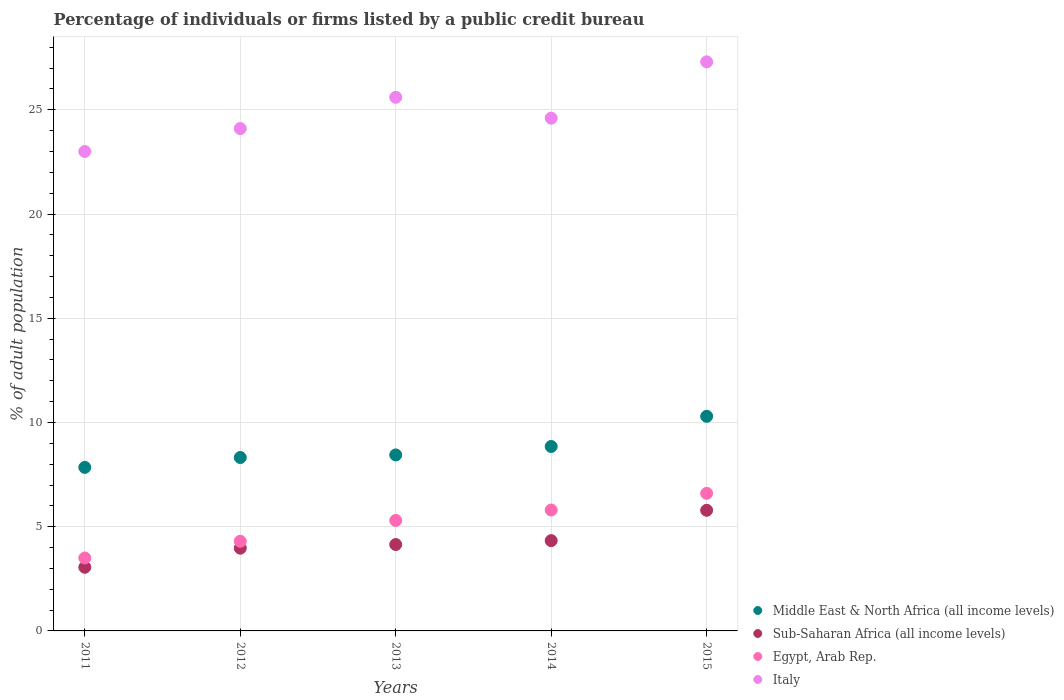What is the percentage of population listed by a public credit bureau in Middle East & North Africa (all income levels) in 2012?
Give a very brief answer. 8.32. Across all years, what is the maximum percentage of population listed by a public credit bureau in Middle East & North Africa (all income levels)?
Provide a short and direct response. 10.3. Across all years, what is the minimum percentage of population listed by a public credit bureau in Middle East & North Africa (all income levels)?
Provide a short and direct response. 7.84. In which year was the percentage of population listed by a public credit bureau in Egypt, Arab Rep. maximum?
Make the answer very short. 2015. What is the total percentage of population listed by a public credit bureau in Middle East & North Africa (all income levels) in the graph?
Provide a succinct answer. 43.75. What is the difference between the percentage of population listed by a public credit bureau in Egypt, Arab Rep. in 2014 and that in 2015?
Give a very brief answer. -0.8. What is the difference between the percentage of population listed by a public credit bureau in Italy in 2011 and the percentage of population listed by a public credit bureau in Sub-Saharan Africa (all income levels) in 2013?
Ensure brevity in your answer.  18.86. What is the average percentage of population listed by a public credit bureau in Middle East & North Africa (all income levels) per year?
Ensure brevity in your answer.  8.75. In the year 2012, what is the difference between the percentage of population listed by a public credit bureau in Sub-Saharan Africa (all income levels) and percentage of population listed by a public credit bureau in Italy?
Keep it short and to the point. -20.13. In how many years, is the percentage of population listed by a public credit bureau in Sub-Saharan Africa (all income levels) greater than 1 %?
Your answer should be compact. 5. What is the ratio of the percentage of population listed by a public credit bureau in Italy in 2013 to that in 2015?
Your response must be concise. 0.94. Is the difference between the percentage of population listed by a public credit bureau in Sub-Saharan Africa (all income levels) in 2012 and 2014 greater than the difference between the percentage of population listed by a public credit bureau in Italy in 2012 and 2014?
Your answer should be very brief. Yes. What is the difference between the highest and the second highest percentage of population listed by a public credit bureau in Italy?
Your answer should be very brief. 1.7. What is the difference between the highest and the lowest percentage of population listed by a public credit bureau in Egypt, Arab Rep.?
Offer a terse response. 3.1. In how many years, is the percentage of population listed by a public credit bureau in Italy greater than the average percentage of population listed by a public credit bureau in Italy taken over all years?
Ensure brevity in your answer.  2. Is it the case that in every year, the sum of the percentage of population listed by a public credit bureau in Sub-Saharan Africa (all income levels) and percentage of population listed by a public credit bureau in Egypt, Arab Rep.  is greater than the sum of percentage of population listed by a public credit bureau in Italy and percentage of population listed by a public credit bureau in Middle East & North Africa (all income levels)?
Make the answer very short. No. Is the percentage of population listed by a public credit bureau in Sub-Saharan Africa (all income levels) strictly greater than the percentage of population listed by a public credit bureau in Egypt, Arab Rep. over the years?
Ensure brevity in your answer.  No. Is the percentage of population listed by a public credit bureau in Sub-Saharan Africa (all income levels) strictly less than the percentage of population listed by a public credit bureau in Middle East & North Africa (all income levels) over the years?
Give a very brief answer. Yes. Are the values on the major ticks of Y-axis written in scientific E-notation?
Give a very brief answer. No. How many legend labels are there?
Your response must be concise. 4. What is the title of the graph?
Make the answer very short. Percentage of individuals or firms listed by a public credit bureau. Does "San Marino" appear as one of the legend labels in the graph?
Provide a short and direct response. No. What is the label or title of the Y-axis?
Provide a succinct answer. % of adult population. What is the % of adult population in Middle East & North Africa (all income levels) in 2011?
Ensure brevity in your answer.  7.84. What is the % of adult population in Sub-Saharan Africa (all income levels) in 2011?
Your answer should be very brief. 3.05. What is the % of adult population in Middle East & North Africa (all income levels) in 2012?
Make the answer very short. 8.32. What is the % of adult population of Sub-Saharan Africa (all income levels) in 2012?
Keep it short and to the point. 3.97. What is the % of adult population in Egypt, Arab Rep. in 2012?
Your answer should be very brief. 4.3. What is the % of adult population in Italy in 2012?
Ensure brevity in your answer.  24.1. What is the % of adult population in Middle East & North Africa (all income levels) in 2013?
Offer a very short reply. 8.44. What is the % of adult population of Sub-Saharan Africa (all income levels) in 2013?
Ensure brevity in your answer.  4.14. What is the % of adult population of Egypt, Arab Rep. in 2013?
Ensure brevity in your answer.  5.3. What is the % of adult population in Italy in 2013?
Make the answer very short. 25.6. What is the % of adult population in Middle East & North Africa (all income levels) in 2014?
Make the answer very short. 8.85. What is the % of adult population in Sub-Saharan Africa (all income levels) in 2014?
Your answer should be very brief. 4.33. What is the % of adult population in Italy in 2014?
Provide a succinct answer. 24.6. What is the % of adult population of Middle East & North Africa (all income levels) in 2015?
Your answer should be very brief. 10.3. What is the % of adult population of Sub-Saharan Africa (all income levels) in 2015?
Make the answer very short. 5.79. What is the % of adult population of Italy in 2015?
Your response must be concise. 27.3. Across all years, what is the maximum % of adult population of Middle East & North Africa (all income levels)?
Make the answer very short. 10.3. Across all years, what is the maximum % of adult population in Sub-Saharan Africa (all income levels)?
Make the answer very short. 5.79. Across all years, what is the maximum % of adult population of Egypt, Arab Rep.?
Your response must be concise. 6.6. Across all years, what is the maximum % of adult population in Italy?
Your answer should be compact. 27.3. Across all years, what is the minimum % of adult population in Middle East & North Africa (all income levels)?
Provide a short and direct response. 7.84. Across all years, what is the minimum % of adult population of Sub-Saharan Africa (all income levels)?
Keep it short and to the point. 3.05. Across all years, what is the minimum % of adult population of Egypt, Arab Rep.?
Offer a very short reply. 3.5. What is the total % of adult population of Middle East & North Africa (all income levels) in the graph?
Offer a terse response. 43.75. What is the total % of adult population of Sub-Saharan Africa (all income levels) in the graph?
Give a very brief answer. 21.29. What is the total % of adult population of Egypt, Arab Rep. in the graph?
Make the answer very short. 25.5. What is the total % of adult population of Italy in the graph?
Give a very brief answer. 124.6. What is the difference between the % of adult population of Middle East & North Africa (all income levels) in 2011 and that in 2012?
Provide a succinct answer. -0.47. What is the difference between the % of adult population of Sub-Saharan Africa (all income levels) in 2011 and that in 2012?
Provide a succinct answer. -0.92. What is the difference between the % of adult population of Italy in 2011 and that in 2012?
Provide a short and direct response. -1.1. What is the difference between the % of adult population of Middle East & North Africa (all income levels) in 2011 and that in 2013?
Offer a very short reply. -0.6. What is the difference between the % of adult population in Sub-Saharan Africa (all income levels) in 2011 and that in 2013?
Make the answer very short. -1.09. What is the difference between the % of adult population of Egypt, Arab Rep. in 2011 and that in 2013?
Ensure brevity in your answer.  -1.8. What is the difference between the % of adult population in Middle East & North Africa (all income levels) in 2011 and that in 2014?
Your answer should be compact. -1. What is the difference between the % of adult population of Sub-Saharan Africa (all income levels) in 2011 and that in 2014?
Ensure brevity in your answer.  -1.28. What is the difference between the % of adult population in Middle East & North Africa (all income levels) in 2011 and that in 2015?
Keep it short and to the point. -2.45. What is the difference between the % of adult population in Sub-Saharan Africa (all income levels) in 2011 and that in 2015?
Provide a short and direct response. -2.73. What is the difference between the % of adult population of Middle East & North Africa (all income levels) in 2012 and that in 2013?
Keep it short and to the point. -0.12. What is the difference between the % of adult population in Sub-Saharan Africa (all income levels) in 2012 and that in 2013?
Make the answer very short. -0.18. What is the difference between the % of adult population in Middle East & North Africa (all income levels) in 2012 and that in 2014?
Your answer should be very brief. -0.53. What is the difference between the % of adult population of Sub-Saharan Africa (all income levels) in 2012 and that in 2014?
Your answer should be compact. -0.36. What is the difference between the % of adult population in Egypt, Arab Rep. in 2012 and that in 2014?
Your answer should be compact. -1.5. What is the difference between the % of adult population in Italy in 2012 and that in 2014?
Keep it short and to the point. -0.5. What is the difference between the % of adult population in Middle East & North Africa (all income levels) in 2012 and that in 2015?
Make the answer very short. -1.98. What is the difference between the % of adult population of Sub-Saharan Africa (all income levels) in 2012 and that in 2015?
Keep it short and to the point. -1.82. What is the difference between the % of adult population of Middle East & North Africa (all income levels) in 2013 and that in 2014?
Give a very brief answer. -0.4. What is the difference between the % of adult population in Sub-Saharan Africa (all income levels) in 2013 and that in 2014?
Your answer should be very brief. -0.19. What is the difference between the % of adult population of Egypt, Arab Rep. in 2013 and that in 2014?
Provide a short and direct response. -0.5. What is the difference between the % of adult population in Italy in 2013 and that in 2014?
Make the answer very short. 1. What is the difference between the % of adult population of Middle East & North Africa (all income levels) in 2013 and that in 2015?
Give a very brief answer. -1.85. What is the difference between the % of adult population in Sub-Saharan Africa (all income levels) in 2013 and that in 2015?
Keep it short and to the point. -1.64. What is the difference between the % of adult population in Middle East & North Africa (all income levels) in 2014 and that in 2015?
Offer a very short reply. -1.45. What is the difference between the % of adult population in Sub-Saharan Africa (all income levels) in 2014 and that in 2015?
Keep it short and to the point. -1.46. What is the difference between the % of adult population of Italy in 2014 and that in 2015?
Give a very brief answer. -2.7. What is the difference between the % of adult population of Middle East & North Africa (all income levels) in 2011 and the % of adult population of Sub-Saharan Africa (all income levels) in 2012?
Keep it short and to the point. 3.88. What is the difference between the % of adult population of Middle East & North Africa (all income levels) in 2011 and the % of adult population of Egypt, Arab Rep. in 2012?
Your answer should be compact. 3.54. What is the difference between the % of adult population of Middle East & North Africa (all income levels) in 2011 and the % of adult population of Italy in 2012?
Your answer should be very brief. -16.25. What is the difference between the % of adult population in Sub-Saharan Africa (all income levels) in 2011 and the % of adult population in Egypt, Arab Rep. in 2012?
Make the answer very short. -1.25. What is the difference between the % of adult population in Sub-Saharan Africa (all income levels) in 2011 and the % of adult population in Italy in 2012?
Provide a succinct answer. -21.05. What is the difference between the % of adult population of Egypt, Arab Rep. in 2011 and the % of adult population of Italy in 2012?
Your answer should be compact. -20.6. What is the difference between the % of adult population of Middle East & North Africa (all income levels) in 2011 and the % of adult population of Sub-Saharan Africa (all income levels) in 2013?
Your answer should be compact. 3.7. What is the difference between the % of adult population in Middle East & North Africa (all income levels) in 2011 and the % of adult population in Egypt, Arab Rep. in 2013?
Your answer should be compact. 2.54. What is the difference between the % of adult population in Middle East & North Africa (all income levels) in 2011 and the % of adult population in Italy in 2013?
Keep it short and to the point. -17.75. What is the difference between the % of adult population in Sub-Saharan Africa (all income levels) in 2011 and the % of adult population in Egypt, Arab Rep. in 2013?
Offer a very short reply. -2.25. What is the difference between the % of adult population of Sub-Saharan Africa (all income levels) in 2011 and the % of adult population of Italy in 2013?
Your response must be concise. -22.55. What is the difference between the % of adult population in Egypt, Arab Rep. in 2011 and the % of adult population in Italy in 2013?
Provide a succinct answer. -22.1. What is the difference between the % of adult population in Middle East & North Africa (all income levels) in 2011 and the % of adult population in Sub-Saharan Africa (all income levels) in 2014?
Give a very brief answer. 3.51. What is the difference between the % of adult population in Middle East & North Africa (all income levels) in 2011 and the % of adult population in Egypt, Arab Rep. in 2014?
Provide a short and direct response. 2.04. What is the difference between the % of adult population in Middle East & North Africa (all income levels) in 2011 and the % of adult population in Italy in 2014?
Provide a succinct answer. -16.75. What is the difference between the % of adult population of Sub-Saharan Africa (all income levels) in 2011 and the % of adult population of Egypt, Arab Rep. in 2014?
Keep it short and to the point. -2.75. What is the difference between the % of adult population in Sub-Saharan Africa (all income levels) in 2011 and the % of adult population in Italy in 2014?
Your answer should be compact. -21.55. What is the difference between the % of adult population in Egypt, Arab Rep. in 2011 and the % of adult population in Italy in 2014?
Your response must be concise. -21.1. What is the difference between the % of adult population of Middle East & North Africa (all income levels) in 2011 and the % of adult population of Sub-Saharan Africa (all income levels) in 2015?
Ensure brevity in your answer.  2.06. What is the difference between the % of adult population in Middle East & North Africa (all income levels) in 2011 and the % of adult population in Egypt, Arab Rep. in 2015?
Provide a short and direct response. 1.25. What is the difference between the % of adult population in Middle East & North Africa (all income levels) in 2011 and the % of adult population in Italy in 2015?
Give a very brief answer. -19.45. What is the difference between the % of adult population in Sub-Saharan Africa (all income levels) in 2011 and the % of adult population in Egypt, Arab Rep. in 2015?
Your answer should be compact. -3.55. What is the difference between the % of adult population in Sub-Saharan Africa (all income levels) in 2011 and the % of adult population in Italy in 2015?
Ensure brevity in your answer.  -24.25. What is the difference between the % of adult population of Egypt, Arab Rep. in 2011 and the % of adult population of Italy in 2015?
Provide a succinct answer. -23.8. What is the difference between the % of adult population of Middle East & North Africa (all income levels) in 2012 and the % of adult population of Sub-Saharan Africa (all income levels) in 2013?
Your answer should be compact. 4.17. What is the difference between the % of adult population of Middle East & North Africa (all income levels) in 2012 and the % of adult population of Egypt, Arab Rep. in 2013?
Ensure brevity in your answer.  3.02. What is the difference between the % of adult population of Middle East & North Africa (all income levels) in 2012 and the % of adult population of Italy in 2013?
Provide a short and direct response. -17.28. What is the difference between the % of adult population in Sub-Saharan Africa (all income levels) in 2012 and the % of adult population in Egypt, Arab Rep. in 2013?
Provide a short and direct response. -1.33. What is the difference between the % of adult population of Sub-Saharan Africa (all income levels) in 2012 and the % of adult population of Italy in 2013?
Your response must be concise. -21.63. What is the difference between the % of adult population of Egypt, Arab Rep. in 2012 and the % of adult population of Italy in 2013?
Make the answer very short. -21.3. What is the difference between the % of adult population of Middle East & North Africa (all income levels) in 2012 and the % of adult population of Sub-Saharan Africa (all income levels) in 2014?
Ensure brevity in your answer.  3.99. What is the difference between the % of adult population of Middle East & North Africa (all income levels) in 2012 and the % of adult population of Egypt, Arab Rep. in 2014?
Ensure brevity in your answer.  2.52. What is the difference between the % of adult population in Middle East & North Africa (all income levels) in 2012 and the % of adult population in Italy in 2014?
Your response must be concise. -16.28. What is the difference between the % of adult population of Sub-Saharan Africa (all income levels) in 2012 and the % of adult population of Egypt, Arab Rep. in 2014?
Your response must be concise. -1.83. What is the difference between the % of adult population of Sub-Saharan Africa (all income levels) in 2012 and the % of adult population of Italy in 2014?
Ensure brevity in your answer.  -20.63. What is the difference between the % of adult population in Egypt, Arab Rep. in 2012 and the % of adult population in Italy in 2014?
Your answer should be compact. -20.3. What is the difference between the % of adult population of Middle East & North Africa (all income levels) in 2012 and the % of adult population of Sub-Saharan Africa (all income levels) in 2015?
Provide a short and direct response. 2.53. What is the difference between the % of adult population in Middle East & North Africa (all income levels) in 2012 and the % of adult population in Egypt, Arab Rep. in 2015?
Your answer should be compact. 1.72. What is the difference between the % of adult population of Middle East & North Africa (all income levels) in 2012 and the % of adult population of Italy in 2015?
Give a very brief answer. -18.98. What is the difference between the % of adult population in Sub-Saharan Africa (all income levels) in 2012 and the % of adult population in Egypt, Arab Rep. in 2015?
Give a very brief answer. -2.63. What is the difference between the % of adult population in Sub-Saharan Africa (all income levels) in 2012 and the % of adult population in Italy in 2015?
Provide a short and direct response. -23.33. What is the difference between the % of adult population of Middle East & North Africa (all income levels) in 2013 and the % of adult population of Sub-Saharan Africa (all income levels) in 2014?
Ensure brevity in your answer.  4.11. What is the difference between the % of adult population of Middle East & North Africa (all income levels) in 2013 and the % of adult population of Egypt, Arab Rep. in 2014?
Offer a very short reply. 2.64. What is the difference between the % of adult population in Middle East & North Africa (all income levels) in 2013 and the % of adult population in Italy in 2014?
Offer a terse response. -16.16. What is the difference between the % of adult population of Sub-Saharan Africa (all income levels) in 2013 and the % of adult population of Egypt, Arab Rep. in 2014?
Offer a very short reply. -1.66. What is the difference between the % of adult population of Sub-Saharan Africa (all income levels) in 2013 and the % of adult population of Italy in 2014?
Your answer should be compact. -20.46. What is the difference between the % of adult population in Egypt, Arab Rep. in 2013 and the % of adult population in Italy in 2014?
Your answer should be compact. -19.3. What is the difference between the % of adult population in Middle East & North Africa (all income levels) in 2013 and the % of adult population in Sub-Saharan Africa (all income levels) in 2015?
Offer a very short reply. 2.66. What is the difference between the % of adult population of Middle East & North Africa (all income levels) in 2013 and the % of adult population of Egypt, Arab Rep. in 2015?
Keep it short and to the point. 1.84. What is the difference between the % of adult population in Middle East & North Africa (all income levels) in 2013 and the % of adult population in Italy in 2015?
Provide a short and direct response. -18.86. What is the difference between the % of adult population in Sub-Saharan Africa (all income levels) in 2013 and the % of adult population in Egypt, Arab Rep. in 2015?
Your answer should be very brief. -2.46. What is the difference between the % of adult population of Sub-Saharan Africa (all income levels) in 2013 and the % of adult population of Italy in 2015?
Offer a very short reply. -23.16. What is the difference between the % of adult population of Egypt, Arab Rep. in 2013 and the % of adult population of Italy in 2015?
Your answer should be compact. -22. What is the difference between the % of adult population of Middle East & North Africa (all income levels) in 2014 and the % of adult population of Sub-Saharan Africa (all income levels) in 2015?
Offer a terse response. 3.06. What is the difference between the % of adult population in Middle East & North Africa (all income levels) in 2014 and the % of adult population in Egypt, Arab Rep. in 2015?
Provide a succinct answer. 2.25. What is the difference between the % of adult population in Middle East & North Africa (all income levels) in 2014 and the % of adult population in Italy in 2015?
Your answer should be compact. -18.45. What is the difference between the % of adult population of Sub-Saharan Africa (all income levels) in 2014 and the % of adult population of Egypt, Arab Rep. in 2015?
Give a very brief answer. -2.27. What is the difference between the % of adult population in Sub-Saharan Africa (all income levels) in 2014 and the % of adult population in Italy in 2015?
Provide a short and direct response. -22.97. What is the difference between the % of adult population in Egypt, Arab Rep. in 2014 and the % of adult population in Italy in 2015?
Keep it short and to the point. -21.5. What is the average % of adult population in Middle East & North Africa (all income levels) per year?
Keep it short and to the point. 8.75. What is the average % of adult population in Sub-Saharan Africa (all income levels) per year?
Ensure brevity in your answer.  4.26. What is the average % of adult population of Egypt, Arab Rep. per year?
Ensure brevity in your answer.  5.1. What is the average % of adult population in Italy per year?
Your answer should be compact. 24.92. In the year 2011, what is the difference between the % of adult population of Middle East & North Africa (all income levels) and % of adult population of Sub-Saharan Africa (all income levels)?
Make the answer very short. 4.79. In the year 2011, what is the difference between the % of adult population of Middle East & North Africa (all income levels) and % of adult population of Egypt, Arab Rep.?
Ensure brevity in your answer.  4.34. In the year 2011, what is the difference between the % of adult population in Middle East & North Africa (all income levels) and % of adult population in Italy?
Give a very brief answer. -15.15. In the year 2011, what is the difference between the % of adult population in Sub-Saharan Africa (all income levels) and % of adult population in Egypt, Arab Rep.?
Offer a terse response. -0.45. In the year 2011, what is the difference between the % of adult population in Sub-Saharan Africa (all income levels) and % of adult population in Italy?
Your answer should be compact. -19.95. In the year 2011, what is the difference between the % of adult population in Egypt, Arab Rep. and % of adult population in Italy?
Your answer should be compact. -19.5. In the year 2012, what is the difference between the % of adult population in Middle East & North Africa (all income levels) and % of adult population in Sub-Saharan Africa (all income levels)?
Give a very brief answer. 4.35. In the year 2012, what is the difference between the % of adult population in Middle East & North Africa (all income levels) and % of adult population in Egypt, Arab Rep.?
Your response must be concise. 4.02. In the year 2012, what is the difference between the % of adult population in Middle East & North Africa (all income levels) and % of adult population in Italy?
Your answer should be very brief. -15.78. In the year 2012, what is the difference between the % of adult population in Sub-Saharan Africa (all income levels) and % of adult population in Egypt, Arab Rep.?
Offer a terse response. -0.33. In the year 2012, what is the difference between the % of adult population of Sub-Saharan Africa (all income levels) and % of adult population of Italy?
Keep it short and to the point. -20.13. In the year 2012, what is the difference between the % of adult population of Egypt, Arab Rep. and % of adult population of Italy?
Keep it short and to the point. -19.8. In the year 2013, what is the difference between the % of adult population in Middle East & North Africa (all income levels) and % of adult population in Sub-Saharan Africa (all income levels)?
Ensure brevity in your answer.  4.3. In the year 2013, what is the difference between the % of adult population of Middle East & North Africa (all income levels) and % of adult population of Egypt, Arab Rep.?
Ensure brevity in your answer.  3.14. In the year 2013, what is the difference between the % of adult population of Middle East & North Africa (all income levels) and % of adult population of Italy?
Give a very brief answer. -17.16. In the year 2013, what is the difference between the % of adult population of Sub-Saharan Africa (all income levels) and % of adult population of Egypt, Arab Rep.?
Offer a terse response. -1.16. In the year 2013, what is the difference between the % of adult population in Sub-Saharan Africa (all income levels) and % of adult population in Italy?
Your answer should be compact. -21.46. In the year 2013, what is the difference between the % of adult population of Egypt, Arab Rep. and % of adult population of Italy?
Provide a succinct answer. -20.3. In the year 2014, what is the difference between the % of adult population in Middle East & North Africa (all income levels) and % of adult population in Sub-Saharan Africa (all income levels)?
Offer a very short reply. 4.52. In the year 2014, what is the difference between the % of adult population in Middle East & North Africa (all income levels) and % of adult population in Egypt, Arab Rep.?
Provide a succinct answer. 3.05. In the year 2014, what is the difference between the % of adult population in Middle East & North Africa (all income levels) and % of adult population in Italy?
Your answer should be compact. -15.75. In the year 2014, what is the difference between the % of adult population in Sub-Saharan Africa (all income levels) and % of adult population in Egypt, Arab Rep.?
Keep it short and to the point. -1.47. In the year 2014, what is the difference between the % of adult population of Sub-Saharan Africa (all income levels) and % of adult population of Italy?
Provide a succinct answer. -20.27. In the year 2014, what is the difference between the % of adult population of Egypt, Arab Rep. and % of adult population of Italy?
Offer a terse response. -18.8. In the year 2015, what is the difference between the % of adult population in Middle East & North Africa (all income levels) and % of adult population in Sub-Saharan Africa (all income levels)?
Make the answer very short. 4.51. In the year 2015, what is the difference between the % of adult population in Middle East & North Africa (all income levels) and % of adult population in Egypt, Arab Rep.?
Provide a short and direct response. 3.7. In the year 2015, what is the difference between the % of adult population in Middle East & North Africa (all income levels) and % of adult population in Italy?
Give a very brief answer. -17. In the year 2015, what is the difference between the % of adult population in Sub-Saharan Africa (all income levels) and % of adult population in Egypt, Arab Rep.?
Offer a very short reply. -0.81. In the year 2015, what is the difference between the % of adult population in Sub-Saharan Africa (all income levels) and % of adult population in Italy?
Your answer should be compact. -21.51. In the year 2015, what is the difference between the % of adult population of Egypt, Arab Rep. and % of adult population of Italy?
Provide a succinct answer. -20.7. What is the ratio of the % of adult population in Middle East & North Africa (all income levels) in 2011 to that in 2012?
Provide a succinct answer. 0.94. What is the ratio of the % of adult population of Sub-Saharan Africa (all income levels) in 2011 to that in 2012?
Ensure brevity in your answer.  0.77. What is the ratio of the % of adult population of Egypt, Arab Rep. in 2011 to that in 2012?
Your answer should be compact. 0.81. What is the ratio of the % of adult population in Italy in 2011 to that in 2012?
Make the answer very short. 0.95. What is the ratio of the % of adult population in Middle East & North Africa (all income levels) in 2011 to that in 2013?
Your answer should be compact. 0.93. What is the ratio of the % of adult population in Sub-Saharan Africa (all income levels) in 2011 to that in 2013?
Your answer should be very brief. 0.74. What is the ratio of the % of adult population of Egypt, Arab Rep. in 2011 to that in 2013?
Provide a succinct answer. 0.66. What is the ratio of the % of adult population of Italy in 2011 to that in 2013?
Your answer should be very brief. 0.9. What is the ratio of the % of adult population of Middle East & North Africa (all income levels) in 2011 to that in 2014?
Provide a short and direct response. 0.89. What is the ratio of the % of adult population in Sub-Saharan Africa (all income levels) in 2011 to that in 2014?
Provide a short and direct response. 0.7. What is the ratio of the % of adult population of Egypt, Arab Rep. in 2011 to that in 2014?
Your answer should be compact. 0.6. What is the ratio of the % of adult population in Italy in 2011 to that in 2014?
Your response must be concise. 0.94. What is the ratio of the % of adult population in Middle East & North Africa (all income levels) in 2011 to that in 2015?
Your response must be concise. 0.76. What is the ratio of the % of adult population of Sub-Saharan Africa (all income levels) in 2011 to that in 2015?
Keep it short and to the point. 0.53. What is the ratio of the % of adult population in Egypt, Arab Rep. in 2011 to that in 2015?
Your response must be concise. 0.53. What is the ratio of the % of adult population in Italy in 2011 to that in 2015?
Offer a very short reply. 0.84. What is the ratio of the % of adult population of Middle East & North Africa (all income levels) in 2012 to that in 2013?
Provide a succinct answer. 0.99. What is the ratio of the % of adult population in Sub-Saharan Africa (all income levels) in 2012 to that in 2013?
Ensure brevity in your answer.  0.96. What is the ratio of the % of adult population of Egypt, Arab Rep. in 2012 to that in 2013?
Your answer should be compact. 0.81. What is the ratio of the % of adult population in Italy in 2012 to that in 2013?
Offer a very short reply. 0.94. What is the ratio of the % of adult population of Middle East & North Africa (all income levels) in 2012 to that in 2014?
Give a very brief answer. 0.94. What is the ratio of the % of adult population in Sub-Saharan Africa (all income levels) in 2012 to that in 2014?
Make the answer very short. 0.92. What is the ratio of the % of adult population in Egypt, Arab Rep. in 2012 to that in 2014?
Ensure brevity in your answer.  0.74. What is the ratio of the % of adult population of Italy in 2012 to that in 2014?
Provide a short and direct response. 0.98. What is the ratio of the % of adult population of Middle East & North Africa (all income levels) in 2012 to that in 2015?
Provide a short and direct response. 0.81. What is the ratio of the % of adult population in Sub-Saharan Africa (all income levels) in 2012 to that in 2015?
Give a very brief answer. 0.69. What is the ratio of the % of adult population of Egypt, Arab Rep. in 2012 to that in 2015?
Your answer should be compact. 0.65. What is the ratio of the % of adult population in Italy in 2012 to that in 2015?
Your answer should be compact. 0.88. What is the ratio of the % of adult population in Middle East & North Africa (all income levels) in 2013 to that in 2014?
Give a very brief answer. 0.95. What is the ratio of the % of adult population in Sub-Saharan Africa (all income levels) in 2013 to that in 2014?
Provide a short and direct response. 0.96. What is the ratio of the % of adult population of Egypt, Arab Rep. in 2013 to that in 2014?
Give a very brief answer. 0.91. What is the ratio of the % of adult population in Italy in 2013 to that in 2014?
Your answer should be very brief. 1.04. What is the ratio of the % of adult population of Middle East & North Africa (all income levels) in 2013 to that in 2015?
Give a very brief answer. 0.82. What is the ratio of the % of adult population in Sub-Saharan Africa (all income levels) in 2013 to that in 2015?
Keep it short and to the point. 0.72. What is the ratio of the % of adult population in Egypt, Arab Rep. in 2013 to that in 2015?
Ensure brevity in your answer.  0.8. What is the ratio of the % of adult population in Italy in 2013 to that in 2015?
Give a very brief answer. 0.94. What is the ratio of the % of adult population in Middle East & North Africa (all income levels) in 2014 to that in 2015?
Keep it short and to the point. 0.86. What is the ratio of the % of adult population in Sub-Saharan Africa (all income levels) in 2014 to that in 2015?
Make the answer very short. 0.75. What is the ratio of the % of adult population in Egypt, Arab Rep. in 2014 to that in 2015?
Your answer should be compact. 0.88. What is the ratio of the % of adult population of Italy in 2014 to that in 2015?
Offer a very short reply. 0.9. What is the difference between the highest and the second highest % of adult population in Middle East & North Africa (all income levels)?
Ensure brevity in your answer.  1.45. What is the difference between the highest and the second highest % of adult population in Sub-Saharan Africa (all income levels)?
Offer a terse response. 1.46. What is the difference between the highest and the second highest % of adult population of Egypt, Arab Rep.?
Give a very brief answer. 0.8. What is the difference between the highest and the lowest % of adult population in Middle East & North Africa (all income levels)?
Make the answer very short. 2.45. What is the difference between the highest and the lowest % of adult population of Sub-Saharan Africa (all income levels)?
Make the answer very short. 2.73. 